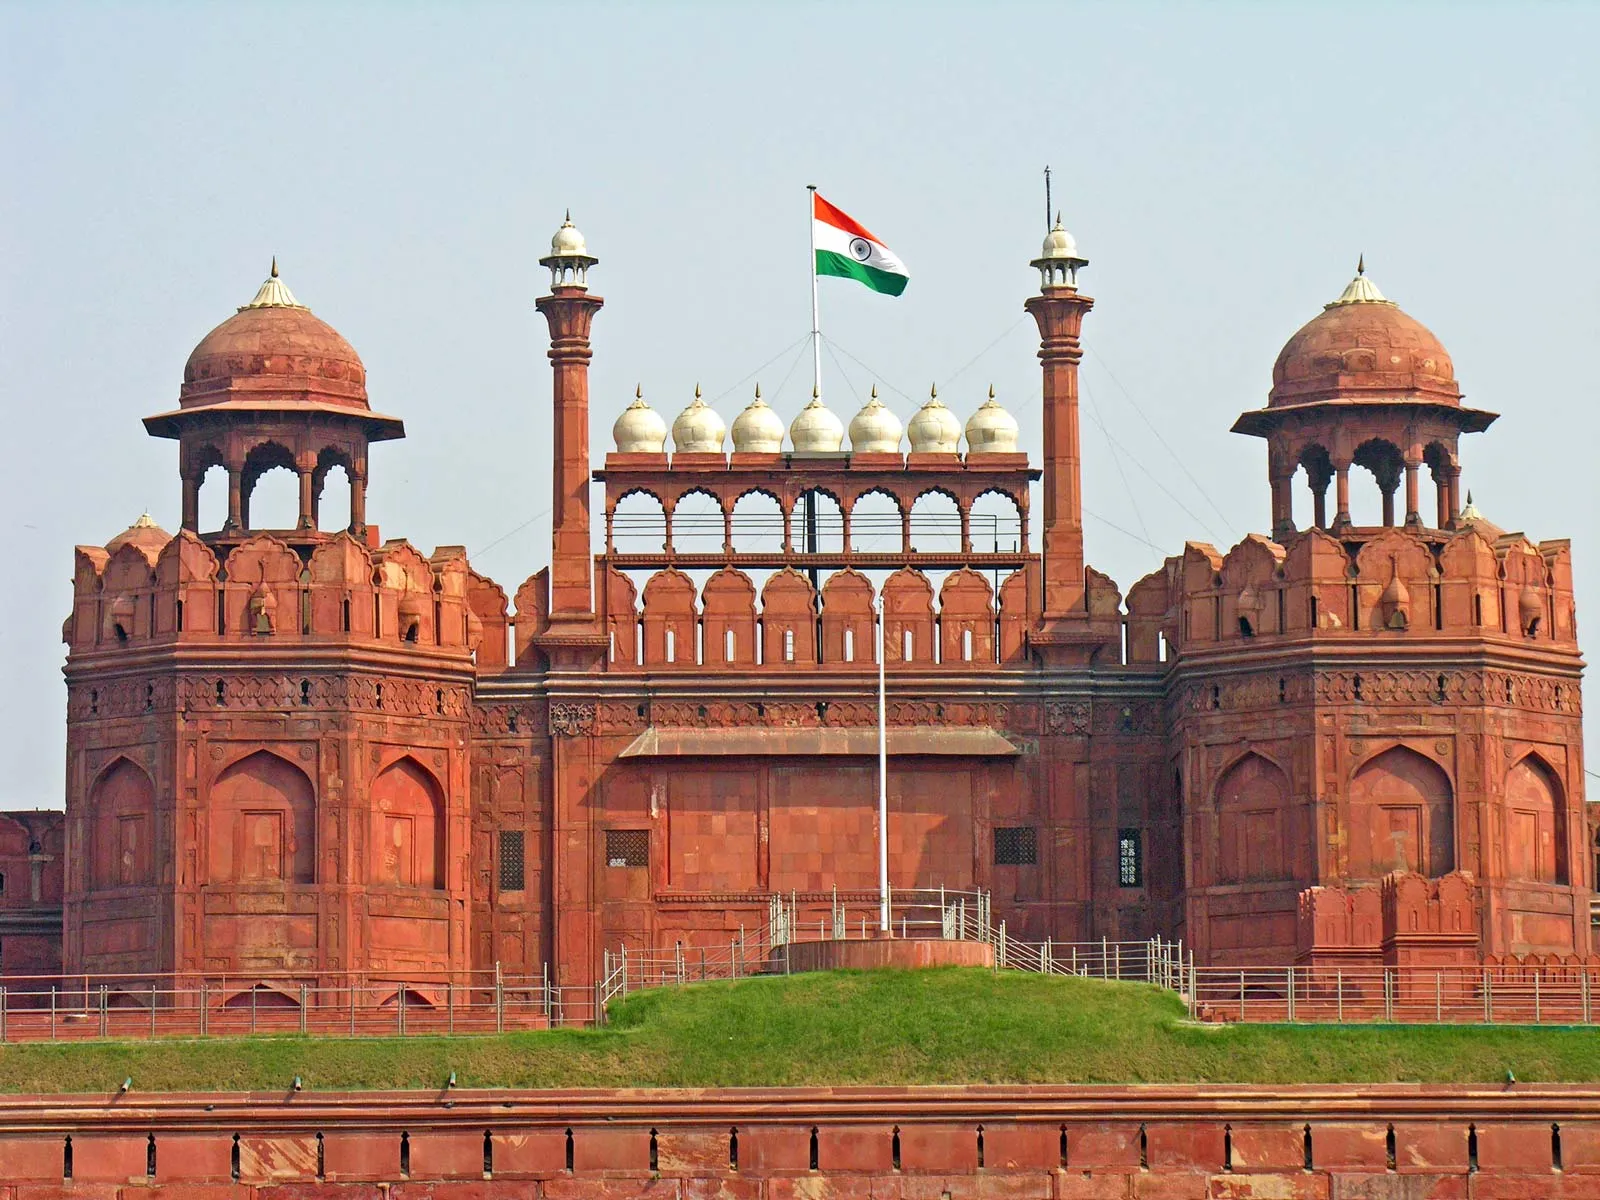What makes this site so important in India’s tourism industry? The Red Fort is a pivotal attraction in India's tourism due to its historical, architectural, and cultural significance. As a UNESCO World Heritage Site, it attracts historians, architects, and tourists from around the world. Its connection to India's Independence Day celebrations adds to its national importance. The intricate Mughal architecture and the well-maintained gardens offer visitors a glimpse into the opulent past of the Mughal era. Its central location in Delhi also makes it easily accessible for tourists. 